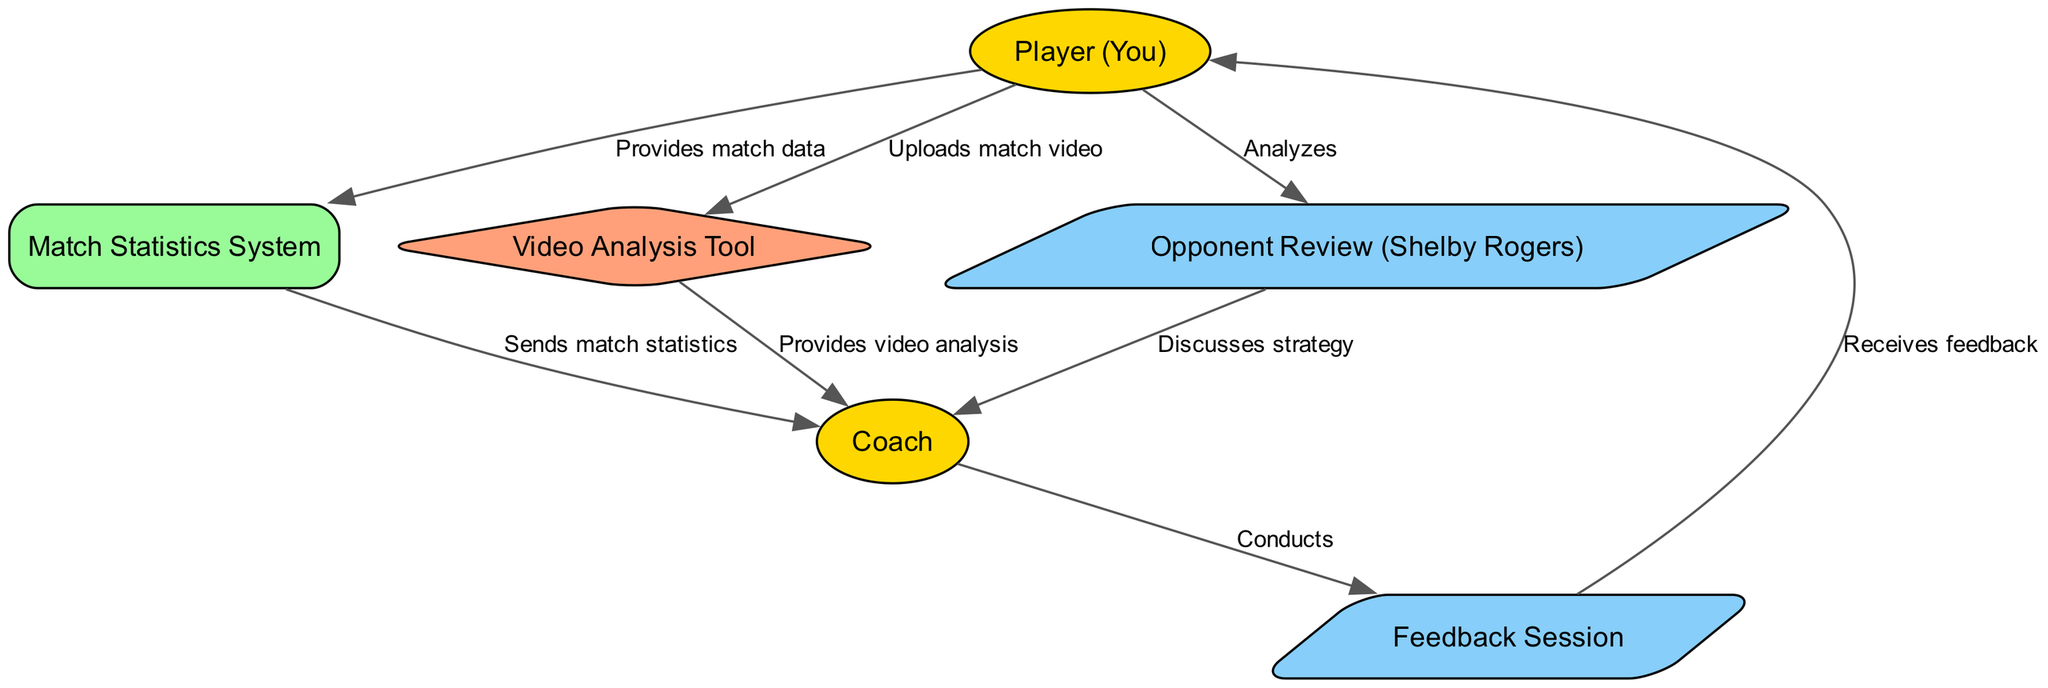What is the first action taken by the Player? The Player initiates the process by providing match data to the Match Statistics System. This is indicated as the first edge from the Player to the System in the diagram.
Answer: Provides match data Which tool does the Player upload the match video to? The Player uploads the match video to the Video Analysis Tool. This action is represented by the direct edge from the Player to the Video Analysis Tool.
Answer: Video Analysis Tool How many activities are depicted in the diagram? The diagram includes four activities: Feedback Session, Opponent Review (Shelby Rogers), plus the Player's interactions with the Match Statistics System and Video Analysis Tool. Therefore, there are three defined activities shown.
Answer: Three Who conducts the feedback session? The Coach conducts the feedback session, as shown by the edge from the Coach to the Feedback Session.
Answer: Coach What is analyzed by the Player after receiving feedback? After receiving feedback, the Player analyzes the Opponent Review, specifically Shelby Rogers. This action is indicated by the edge from the Player to the Opponent Review.
Answer: Opponent Review (Shelby Rogers) What type of system receives match statistics? The Match Statistics System receives match data from the Player, which is a systematic process. The type indicated in the diagram is categorized as a System.
Answer: System What follows after the Player uploads the match video? After the Player uploads the match video to the Video Analysis Tool, the Tool provides video analysis to the Coach. This flow is represented by the edge leading from the Video Analysis Tool to the Coach.
Answer: Provides video analysis How is the strategy for the match discussed? The strategy for the match is discussed between the Opponent Review and the Coach, evidenced by the edge connecting the two activities in the diagram.
Answer: Discusses strategy 